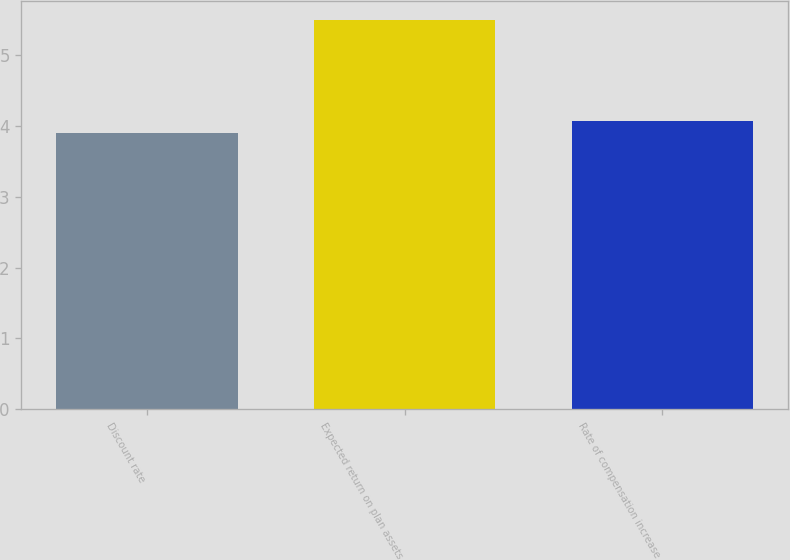Convert chart. <chart><loc_0><loc_0><loc_500><loc_500><bar_chart><fcel>Discount rate<fcel>Expected return on plan assets<fcel>Rate of compensation increase<nl><fcel>3.91<fcel>5.5<fcel>4.07<nl></chart> 